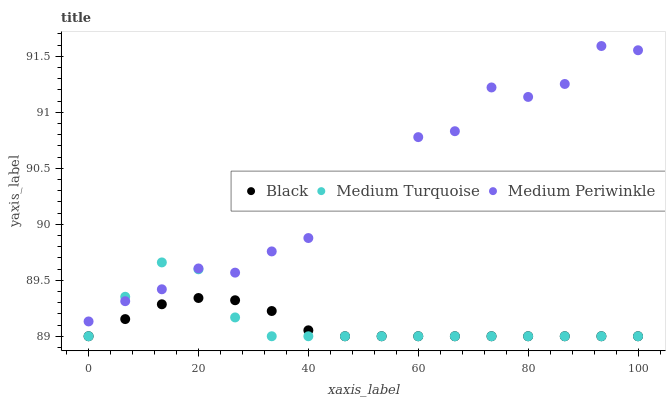Does Black have the minimum area under the curve?
Answer yes or no. Yes. Does Medium Periwinkle have the maximum area under the curve?
Answer yes or no. Yes. Does Medium Turquoise have the minimum area under the curve?
Answer yes or no. No. Does Medium Turquoise have the maximum area under the curve?
Answer yes or no. No. Is Black the smoothest?
Answer yes or no. Yes. Is Medium Periwinkle the roughest?
Answer yes or no. Yes. Is Medium Turquoise the smoothest?
Answer yes or no. No. Is Medium Turquoise the roughest?
Answer yes or no. No. Does Black have the lowest value?
Answer yes or no. Yes. Does Medium Periwinkle have the highest value?
Answer yes or no. Yes. Does Medium Turquoise have the highest value?
Answer yes or no. No. Is Black less than Medium Periwinkle?
Answer yes or no. Yes. Is Medium Periwinkle greater than Black?
Answer yes or no. Yes. Does Black intersect Medium Turquoise?
Answer yes or no. Yes. Is Black less than Medium Turquoise?
Answer yes or no. No. Is Black greater than Medium Turquoise?
Answer yes or no. No. Does Black intersect Medium Periwinkle?
Answer yes or no. No. 